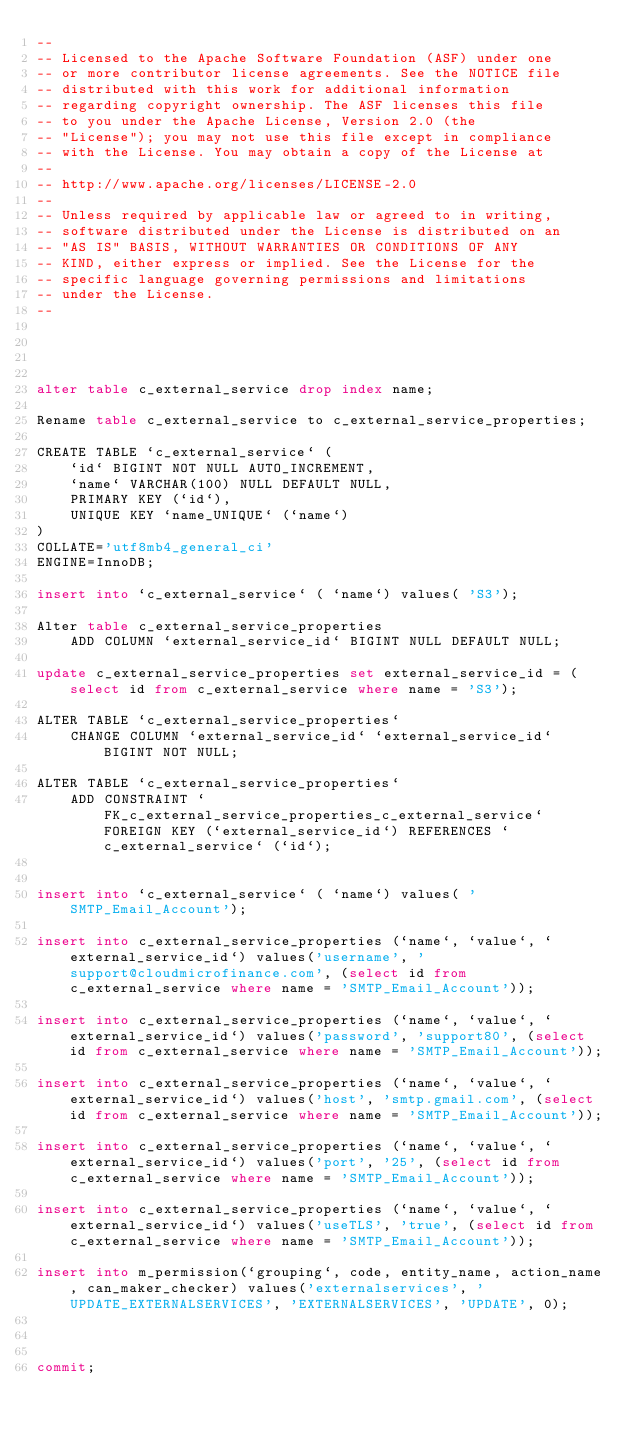<code> <loc_0><loc_0><loc_500><loc_500><_SQL_>--
-- Licensed to the Apache Software Foundation (ASF) under one
-- or more contributor license agreements. See the NOTICE file
-- distributed with this work for additional information
-- regarding copyright ownership. The ASF licenses this file
-- to you under the Apache License, Version 2.0 (the
-- "License"); you may not use this file except in compliance
-- with the License. You may obtain a copy of the License at
--
-- http://www.apache.org/licenses/LICENSE-2.0
--
-- Unless required by applicable law or agreed to in writing,
-- software distributed under the License is distributed on an
-- "AS IS" BASIS, WITHOUT WARRANTIES OR CONDITIONS OF ANY
-- KIND, either express or implied. See the License for the
-- specific language governing permissions and limitations
-- under the License.
--




alter table c_external_service drop index name;

Rename table c_external_service to c_external_service_properties;

CREATE TABLE `c_external_service` (
    `id` BIGINT NOT NULL AUTO_INCREMENT,
    `name` VARCHAR(100) NULL DEFAULT NULL,
    PRIMARY KEY (`id`),
    UNIQUE KEY `name_UNIQUE` (`name`)
)
COLLATE='utf8mb4_general_ci'
ENGINE=InnoDB;

insert into `c_external_service` ( `name`) values( 'S3');

Alter table c_external_service_properties
    ADD COLUMN `external_service_id` BIGINT NULL DEFAULT NULL;

update c_external_service_properties set external_service_id = (select id from c_external_service where name = 'S3');

ALTER TABLE `c_external_service_properties`
    CHANGE COLUMN `external_service_id` `external_service_id` BIGINT NOT NULL;

ALTER TABLE `c_external_service_properties`
    ADD CONSTRAINT `FK_c_external_service_properties_c_external_service` FOREIGN KEY (`external_service_id`) REFERENCES `c_external_service` (`id`);


insert into `c_external_service` ( `name`) values( 'SMTP_Email_Account');

insert into c_external_service_properties (`name`, `value`, `external_service_id`) values('username', 'support@cloudmicrofinance.com', (select id from c_external_service where name = 'SMTP_Email_Account'));

insert into c_external_service_properties (`name`, `value`, `external_service_id`) values('password', 'support80', (select id from c_external_service where name = 'SMTP_Email_Account'));

insert into c_external_service_properties (`name`, `value`, `external_service_id`) values('host', 'smtp.gmail.com', (select id from c_external_service where name = 'SMTP_Email_Account'));

insert into c_external_service_properties (`name`, `value`, `external_service_id`) values('port', '25', (select id from c_external_service where name = 'SMTP_Email_Account'));

insert into c_external_service_properties (`name`, `value`, `external_service_id`) values('useTLS', 'true', (select id from c_external_service where name = 'SMTP_Email_Account'));

insert into m_permission(`grouping`, code, entity_name, action_name, can_maker_checker) values('externalservices', 'UPDATE_EXTERNALSERVICES', 'EXTERNALSERVICES', 'UPDATE', 0);



commit;
</code> 